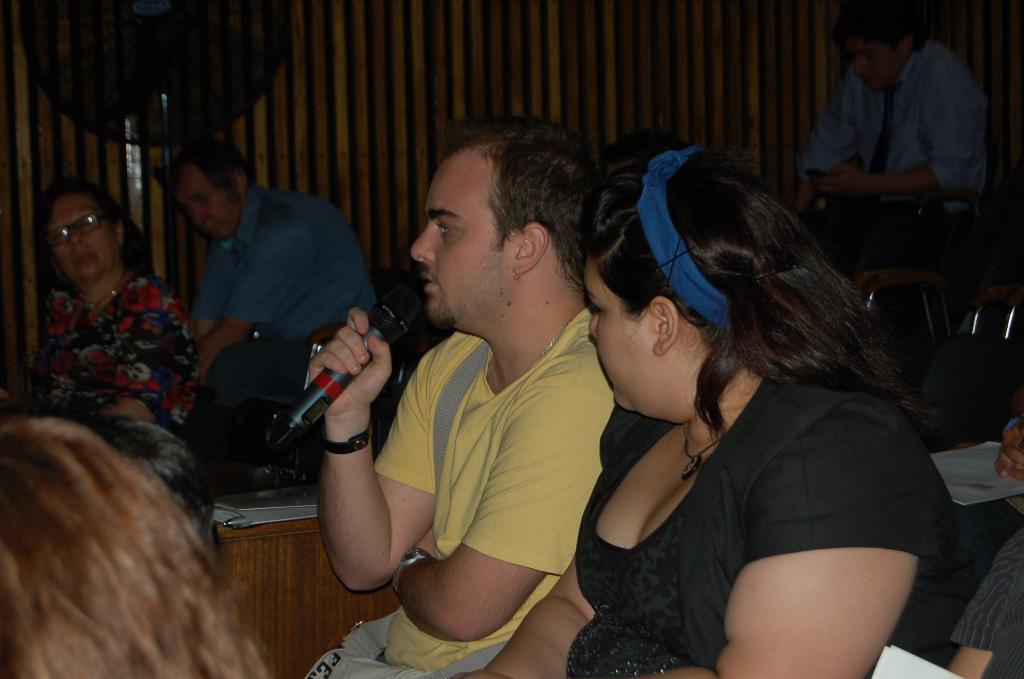Describe this image in one or two sentences. In this image we can see this person wearing yellow T-shirt is holding a mic in his hands. In the background, we can see these people are sitting and a wooden wall here. 